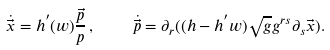<formula> <loc_0><loc_0><loc_500><loc_500>\dot { \vec { x } } = h ^ { ^ { \prime } } ( w ) \frac { \vec { p } } { p } \, , \quad \dot { \vec { p } } = \partial _ { r } ( ( h - h ^ { ^ { \prime } } w ) \sqrt { g } g ^ { r s } \partial _ { s } \vec { x } ) .</formula> 